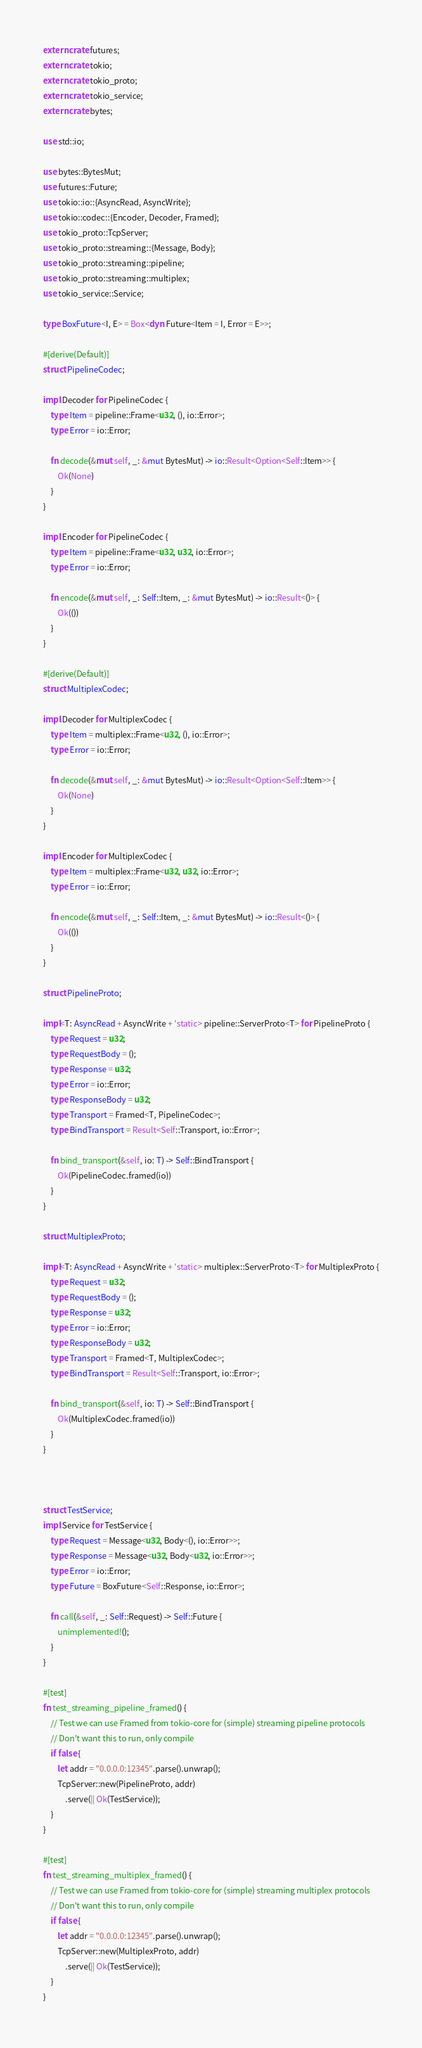Convert code to text. <code><loc_0><loc_0><loc_500><loc_500><_Rust_>extern crate futures;
extern crate tokio;
extern crate tokio_proto;
extern crate tokio_service;
extern crate bytes;

use std::io;

use bytes::BytesMut;
use futures::Future;
use tokio::io::{AsyncRead, AsyncWrite};
use tokio::codec::{Encoder, Decoder, Framed};
use tokio_proto::TcpServer;
use tokio_proto::streaming::{Message, Body};
use tokio_proto::streaming::pipeline;
use tokio_proto::streaming::multiplex;
use tokio_service::Service;

type BoxFuture<I, E> = Box<dyn Future<Item = I, Error = E>>;

#[derive(Default)]
struct PipelineCodec;

impl Decoder for PipelineCodec {
    type Item = pipeline::Frame<u32, (), io::Error>;
    type Error = io::Error;

    fn decode(&mut self, _: &mut BytesMut) -> io::Result<Option<Self::Item>> {
        Ok(None)
    }
}

impl Encoder for PipelineCodec {
    type Item = pipeline::Frame<u32, u32, io::Error>;
    type Error = io::Error;

    fn encode(&mut self, _: Self::Item, _: &mut BytesMut) -> io::Result<()> {
        Ok(())
    }
}

#[derive(Default)]
struct MultiplexCodec;

impl Decoder for MultiplexCodec {
    type Item = multiplex::Frame<u32, (), io::Error>;
    type Error = io::Error;

    fn decode(&mut self, _: &mut BytesMut) -> io::Result<Option<Self::Item>> {
        Ok(None)
    }
}

impl Encoder for MultiplexCodec {
    type Item = multiplex::Frame<u32, u32, io::Error>;
    type Error = io::Error;

    fn encode(&mut self, _: Self::Item, _: &mut BytesMut) -> io::Result<()> {
        Ok(())
    }
}

struct PipelineProto;

impl<T: AsyncRead + AsyncWrite + 'static> pipeline::ServerProto<T> for PipelineProto {
    type Request = u32;
    type RequestBody = ();
    type Response = u32;
    type Error = io::Error;
    type ResponseBody = u32;
    type Transport = Framed<T, PipelineCodec>;
    type BindTransport = Result<Self::Transport, io::Error>;

    fn bind_transport(&self, io: T) -> Self::BindTransport {
        Ok(PipelineCodec.framed(io))
    }
}

struct MultiplexProto;

impl<T: AsyncRead + AsyncWrite + 'static> multiplex::ServerProto<T> for MultiplexProto {
    type Request = u32;
    type RequestBody = ();
    type Response = u32;
    type Error = io::Error;
    type ResponseBody = u32;
    type Transport = Framed<T, MultiplexCodec>;
    type BindTransport = Result<Self::Transport, io::Error>;

    fn bind_transport(&self, io: T) -> Self::BindTransport {
        Ok(MultiplexCodec.framed(io))
    }
}



struct TestService;
impl Service for TestService {
    type Request = Message<u32, Body<(), io::Error>>;
    type Response = Message<u32, Body<u32, io::Error>>;
    type Error = io::Error;
    type Future = BoxFuture<Self::Response, io::Error>;

    fn call(&self, _: Self::Request) -> Self::Future {
        unimplemented!();
    }
}

#[test]
fn test_streaming_pipeline_framed() {
    // Test we can use Framed from tokio-core for (simple) streaming pipeline protocols
    // Don't want this to run, only compile
    if false {
        let addr = "0.0.0.0:12345".parse().unwrap();
        TcpServer::new(PipelineProto, addr)
            .serve(|| Ok(TestService));
    }
}

#[test]
fn test_streaming_multiplex_framed() {
    // Test we can use Framed from tokio-core for (simple) streaming multiplex protocols
    // Don't want this to run, only compile
    if false {
        let addr = "0.0.0.0:12345".parse().unwrap();
        TcpServer::new(MultiplexProto, addr)
            .serve(|| Ok(TestService));
    }
}
</code> 